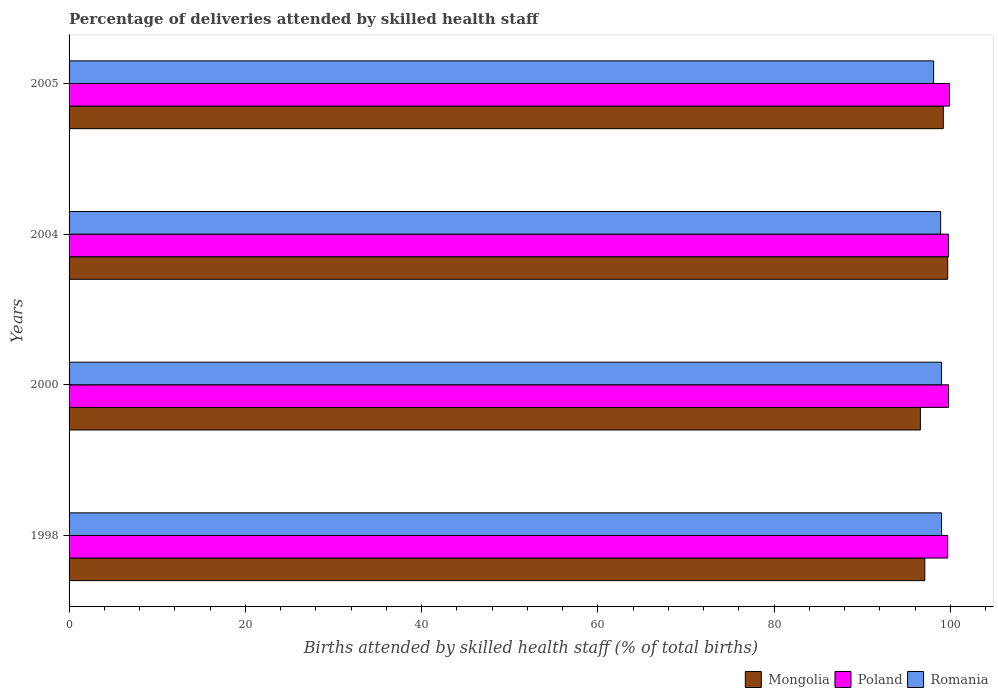How many different coloured bars are there?
Ensure brevity in your answer.  3. How many groups of bars are there?
Offer a very short reply. 4. Are the number of bars per tick equal to the number of legend labels?
Your answer should be compact. Yes. What is the label of the 3rd group of bars from the top?
Offer a very short reply. 2000. What is the percentage of births attended by skilled health staff in Poland in 1998?
Your answer should be very brief. 99.7. Across all years, what is the maximum percentage of births attended by skilled health staff in Mongolia?
Provide a short and direct response. 99.7. Across all years, what is the minimum percentage of births attended by skilled health staff in Romania?
Keep it short and to the point. 98.1. In which year was the percentage of births attended by skilled health staff in Romania maximum?
Your response must be concise. 1998. In which year was the percentage of births attended by skilled health staff in Poland minimum?
Keep it short and to the point. 1998. What is the total percentage of births attended by skilled health staff in Poland in the graph?
Your answer should be compact. 399.2. What is the difference between the percentage of births attended by skilled health staff in Romania in 2000 and that in 2005?
Provide a short and direct response. 0.9. What is the difference between the percentage of births attended by skilled health staff in Mongolia in 2004 and the percentage of births attended by skilled health staff in Romania in 1998?
Provide a succinct answer. 0.7. What is the average percentage of births attended by skilled health staff in Mongolia per year?
Offer a terse response. 98.15. In the year 2004, what is the difference between the percentage of births attended by skilled health staff in Mongolia and percentage of births attended by skilled health staff in Poland?
Offer a terse response. -0.1. What is the ratio of the percentage of births attended by skilled health staff in Poland in 2000 to that in 2004?
Keep it short and to the point. 1. Is the difference between the percentage of births attended by skilled health staff in Mongolia in 2004 and 2005 greater than the difference between the percentage of births attended by skilled health staff in Poland in 2004 and 2005?
Give a very brief answer. Yes. What is the difference between the highest and the second highest percentage of births attended by skilled health staff in Romania?
Offer a very short reply. 0. What is the difference between the highest and the lowest percentage of births attended by skilled health staff in Mongolia?
Your answer should be very brief. 3.1. Is the sum of the percentage of births attended by skilled health staff in Poland in 2004 and 2005 greater than the maximum percentage of births attended by skilled health staff in Romania across all years?
Keep it short and to the point. Yes. What does the 3rd bar from the top in 2005 represents?
Offer a very short reply. Mongolia. What does the 2nd bar from the bottom in 2000 represents?
Your answer should be compact. Poland. Are all the bars in the graph horizontal?
Offer a very short reply. Yes. Are the values on the major ticks of X-axis written in scientific E-notation?
Offer a very short reply. No. Does the graph contain any zero values?
Your response must be concise. No. Does the graph contain grids?
Your answer should be very brief. No. Where does the legend appear in the graph?
Your answer should be compact. Bottom right. How are the legend labels stacked?
Your response must be concise. Horizontal. What is the title of the graph?
Ensure brevity in your answer.  Percentage of deliveries attended by skilled health staff. Does "Luxembourg" appear as one of the legend labels in the graph?
Offer a terse response. No. What is the label or title of the X-axis?
Make the answer very short. Births attended by skilled health staff (% of total births). What is the Births attended by skilled health staff (% of total births) of Mongolia in 1998?
Provide a short and direct response. 97.1. What is the Births attended by skilled health staff (% of total births) in Poland in 1998?
Your answer should be compact. 99.7. What is the Births attended by skilled health staff (% of total births) of Mongolia in 2000?
Provide a short and direct response. 96.6. What is the Births attended by skilled health staff (% of total births) of Poland in 2000?
Your answer should be very brief. 99.8. What is the Births attended by skilled health staff (% of total births) in Romania in 2000?
Offer a very short reply. 99. What is the Births attended by skilled health staff (% of total births) in Mongolia in 2004?
Ensure brevity in your answer.  99.7. What is the Births attended by skilled health staff (% of total births) in Poland in 2004?
Provide a short and direct response. 99.8. What is the Births attended by skilled health staff (% of total births) of Romania in 2004?
Your answer should be very brief. 98.9. What is the Births attended by skilled health staff (% of total births) in Mongolia in 2005?
Ensure brevity in your answer.  99.2. What is the Births attended by skilled health staff (% of total births) of Poland in 2005?
Give a very brief answer. 99.9. What is the Births attended by skilled health staff (% of total births) of Romania in 2005?
Your answer should be compact. 98.1. Across all years, what is the maximum Births attended by skilled health staff (% of total births) of Mongolia?
Your answer should be very brief. 99.7. Across all years, what is the maximum Births attended by skilled health staff (% of total births) in Poland?
Your answer should be compact. 99.9. Across all years, what is the maximum Births attended by skilled health staff (% of total births) of Romania?
Offer a very short reply. 99. Across all years, what is the minimum Births attended by skilled health staff (% of total births) in Mongolia?
Make the answer very short. 96.6. Across all years, what is the minimum Births attended by skilled health staff (% of total births) in Poland?
Provide a succinct answer. 99.7. Across all years, what is the minimum Births attended by skilled health staff (% of total births) of Romania?
Provide a short and direct response. 98.1. What is the total Births attended by skilled health staff (% of total births) of Mongolia in the graph?
Your answer should be compact. 392.6. What is the total Births attended by skilled health staff (% of total births) in Poland in the graph?
Make the answer very short. 399.2. What is the total Births attended by skilled health staff (% of total births) of Romania in the graph?
Give a very brief answer. 395. What is the difference between the Births attended by skilled health staff (% of total births) of Romania in 1998 and that in 2004?
Provide a succinct answer. 0.1. What is the difference between the Births attended by skilled health staff (% of total births) of Mongolia in 1998 and that in 2005?
Provide a succinct answer. -2.1. What is the difference between the Births attended by skilled health staff (% of total births) of Mongolia in 2000 and that in 2004?
Your answer should be compact. -3.1. What is the difference between the Births attended by skilled health staff (% of total births) in Poland in 2000 and that in 2004?
Provide a succinct answer. 0. What is the difference between the Births attended by skilled health staff (% of total births) in Romania in 2000 and that in 2005?
Your answer should be compact. 0.9. What is the difference between the Births attended by skilled health staff (% of total births) in Poland in 1998 and the Births attended by skilled health staff (% of total births) in Romania in 2000?
Give a very brief answer. 0.7. What is the difference between the Births attended by skilled health staff (% of total births) in Mongolia in 1998 and the Births attended by skilled health staff (% of total births) in Poland in 2004?
Your answer should be very brief. -2.7. What is the difference between the Births attended by skilled health staff (% of total births) of Mongolia in 1998 and the Births attended by skilled health staff (% of total births) of Romania in 2004?
Your response must be concise. -1.8. What is the difference between the Births attended by skilled health staff (% of total births) of Mongolia in 1998 and the Births attended by skilled health staff (% of total births) of Romania in 2005?
Your answer should be compact. -1. What is the difference between the Births attended by skilled health staff (% of total births) of Mongolia in 2000 and the Births attended by skilled health staff (% of total births) of Poland in 2004?
Your answer should be compact. -3.2. What is the difference between the Births attended by skilled health staff (% of total births) of Mongolia in 2000 and the Births attended by skilled health staff (% of total births) of Romania in 2004?
Offer a terse response. -2.3. What is the difference between the Births attended by skilled health staff (% of total births) in Mongolia in 2004 and the Births attended by skilled health staff (% of total births) in Romania in 2005?
Provide a short and direct response. 1.6. What is the average Births attended by skilled health staff (% of total births) in Mongolia per year?
Offer a very short reply. 98.15. What is the average Births attended by skilled health staff (% of total births) in Poland per year?
Your answer should be compact. 99.8. What is the average Births attended by skilled health staff (% of total births) of Romania per year?
Offer a terse response. 98.75. In the year 1998, what is the difference between the Births attended by skilled health staff (% of total births) in Mongolia and Births attended by skilled health staff (% of total births) in Poland?
Your answer should be very brief. -2.6. In the year 1998, what is the difference between the Births attended by skilled health staff (% of total births) in Mongolia and Births attended by skilled health staff (% of total births) in Romania?
Give a very brief answer. -1.9. In the year 2000, what is the difference between the Births attended by skilled health staff (% of total births) in Mongolia and Births attended by skilled health staff (% of total births) in Romania?
Offer a terse response. -2.4. In the year 2000, what is the difference between the Births attended by skilled health staff (% of total births) in Poland and Births attended by skilled health staff (% of total births) in Romania?
Keep it short and to the point. 0.8. In the year 2004, what is the difference between the Births attended by skilled health staff (% of total births) in Mongolia and Births attended by skilled health staff (% of total births) in Poland?
Provide a succinct answer. -0.1. In the year 2005, what is the difference between the Births attended by skilled health staff (% of total births) in Mongolia and Births attended by skilled health staff (% of total births) in Poland?
Give a very brief answer. -0.7. What is the ratio of the Births attended by skilled health staff (% of total births) in Mongolia in 1998 to that in 2000?
Offer a very short reply. 1.01. What is the ratio of the Births attended by skilled health staff (% of total births) of Mongolia in 1998 to that in 2004?
Give a very brief answer. 0.97. What is the ratio of the Births attended by skilled health staff (% of total births) in Poland in 1998 to that in 2004?
Your answer should be very brief. 1. What is the ratio of the Births attended by skilled health staff (% of total births) of Mongolia in 1998 to that in 2005?
Make the answer very short. 0.98. What is the ratio of the Births attended by skilled health staff (% of total births) in Poland in 1998 to that in 2005?
Give a very brief answer. 1. What is the ratio of the Births attended by skilled health staff (% of total births) in Romania in 1998 to that in 2005?
Ensure brevity in your answer.  1.01. What is the ratio of the Births attended by skilled health staff (% of total births) of Mongolia in 2000 to that in 2004?
Your response must be concise. 0.97. What is the ratio of the Births attended by skilled health staff (% of total births) of Romania in 2000 to that in 2004?
Provide a succinct answer. 1. What is the ratio of the Births attended by skilled health staff (% of total births) of Mongolia in 2000 to that in 2005?
Make the answer very short. 0.97. What is the ratio of the Births attended by skilled health staff (% of total births) of Romania in 2000 to that in 2005?
Make the answer very short. 1.01. What is the ratio of the Births attended by skilled health staff (% of total births) in Poland in 2004 to that in 2005?
Offer a terse response. 1. What is the ratio of the Births attended by skilled health staff (% of total births) in Romania in 2004 to that in 2005?
Give a very brief answer. 1.01. What is the difference between the highest and the second highest Births attended by skilled health staff (% of total births) in Mongolia?
Make the answer very short. 0.5. What is the difference between the highest and the second highest Births attended by skilled health staff (% of total births) of Poland?
Provide a short and direct response. 0.1. What is the difference between the highest and the second highest Births attended by skilled health staff (% of total births) of Romania?
Make the answer very short. 0. What is the difference between the highest and the lowest Births attended by skilled health staff (% of total births) in Romania?
Make the answer very short. 0.9. 